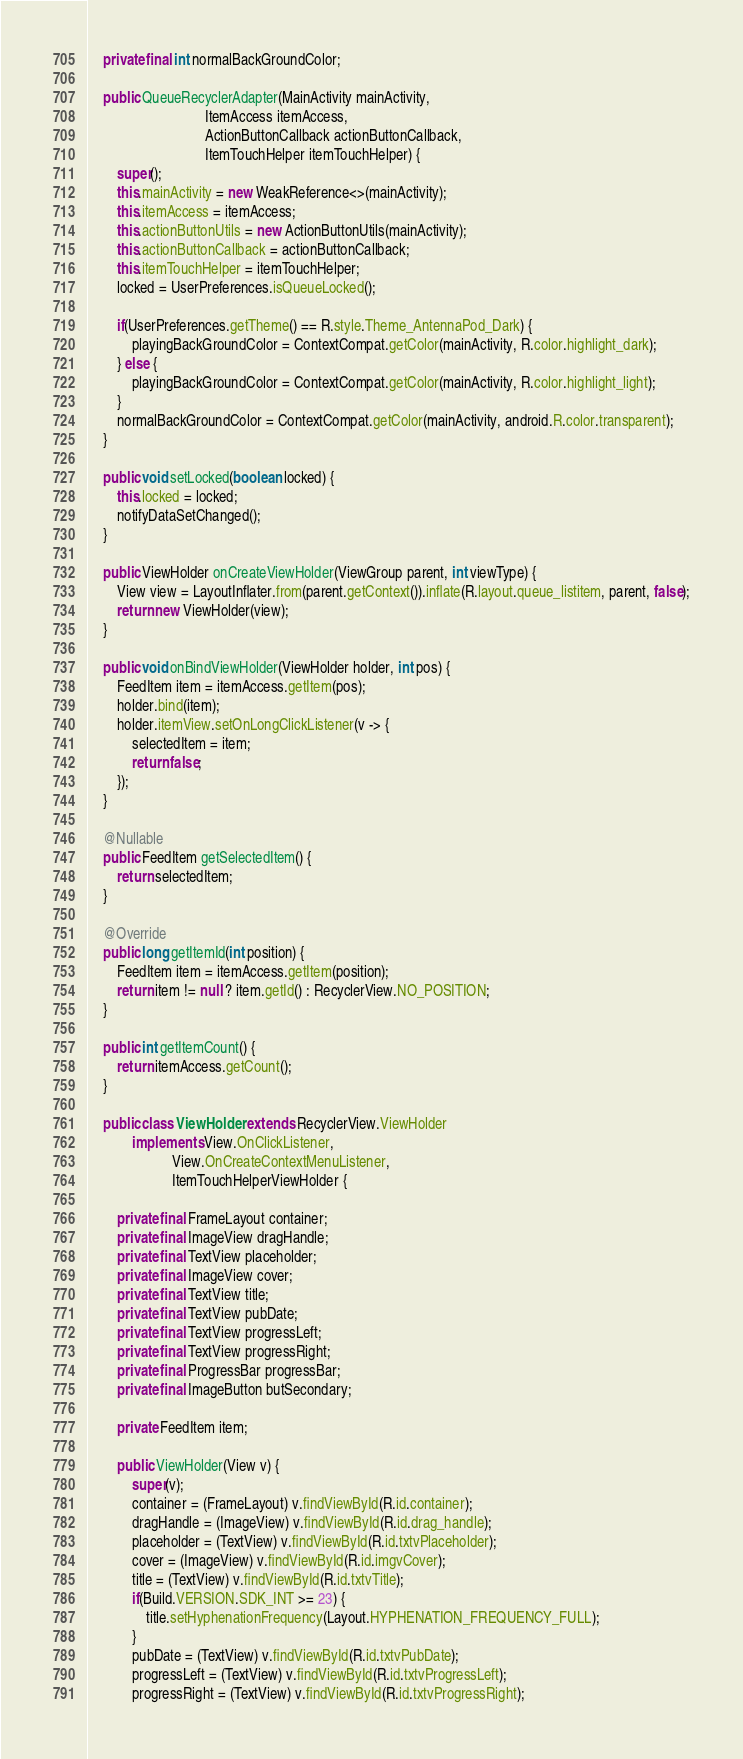Convert code to text. <code><loc_0><loc_0><loc_500><loc_500><_Java_>    private final int normalBackGroundColor;

    public QueueRecyclerAdapter(MainActivity mainActivity,
                                ItemAccess itemAccess,
                                ActionButtonCallback actionButtonCallback,
                                ItemTouchHelper itemTouchHelper) {
        super();
        this.mainActivity = new WeakReference<>(mainActivity);
        this.itemAccess = itemAccess;
        this.actionButtonUtils = new ActionButtonUtils(mainActivity);
        this.actionButtonCallback = actionButtonCallback;
        this.itemTouchHelper = itemTouchHelper;
        locked = UserPreferences.isQueueLocked();

        if(UserPreferences.getTheme() == R.style.Theme_AntennaPod_Dark) {
            playingBackGroundColor = ContextCompat.getColor(mainActivity, R.color.highlight_dark);
        } else {
            playingBackGroundColor = ContextCompat.getColor(mainActivity, R.color.highlight_light);
        }
        normalBackGroundColor = ContextCompat.getColor(mainActivity, android.R.color.transparent);
    }

    public void setLocked(boolean locked) {
        this.locked = locked;
        notifyDataSetChanged();
    }

    public ViewHolder onCreateViewHolder(ViewGroup parent, int viewType) {
        View view = LayoutInflater.from(parent.getContext()).inflate(R.layout.queue_listitem, parent, false);
        return new ViewHolder(view);
    }

    public void onBindViewHolder(ViewHolder holder, int pos) {
        FeedItem item = itemAccess.getItem(pos);
        holder.bind(item);
        holder.itemView.setOnLongClickListener(v -> {
            selectedItem = item;
            return false;
        });
    }

    @Nullable
    public FeedItem getSelectedItem() {
        return selectedItem;
    }

    @Override
    public long getItemId(int position) {
        FeedItem item = itemAccess.getItem(position);
        return item != null ? item.getId() : RecyclerView.NO_POSITION;
    }

    public int getItemCount() {
        return itemAccess.getCount();
    }

    public class ViewHolder extends RecyclerView.ViewHolder
            implements View.OnClickListener,
                       View.OnCreateContextMenuListener,
                       ItemTouchHelperViewHolder {

        private final FrameLayout container;
        private final ImageView dragHandle;
        private final TextView placeholder;
        private final ImageView cover;
        private final TextView title;
        private final TextView pubDate;
        private final TextView progressLeft;
        private final TextView progressRight;
        private final ProgressBar progressBar;
        private final ImageButton butSecondary;
        
        private FeedItem item;

        public ViewHolder(View v) {
            super(v);
            container = (FrameLayout) v.findViewById(R.id.container);
            dragHandle = (ImageView) v.findViewById(R.id.drag_handle);
            placeholder = (TextView) v.findViewById(R.id.txtvPlaceholder);
            cover = (ImageView) v.findViewById(R.id.imgvCover);
            title = (TextView) v.findViewById(R.id.txtvTitle);
            if(Build.VERSION.SDK_INT >= 23) {
                title.setHyphenationFrequency(Layout.HYPHENATION_FREQUENCY_FULL);
            }
            pubDate = (TextView) v.findViewById(R.id.txtvPubDate);
            progressLeft = (TextView) v.findViewById(R.id.txtvProgressLeft);
            progressRight = (TextView) v.findViewById(R.id.txtvProgressRight);</code> 